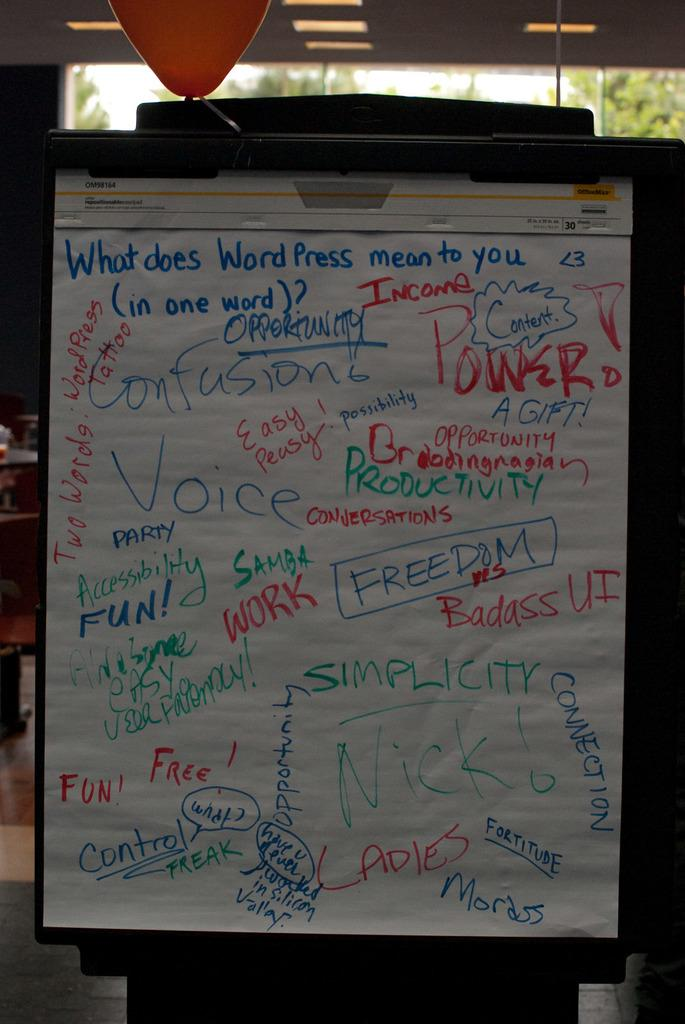<image>
Describe the image concisely. A large sheet of paper detailing the meaning of Word Press is displayed. 